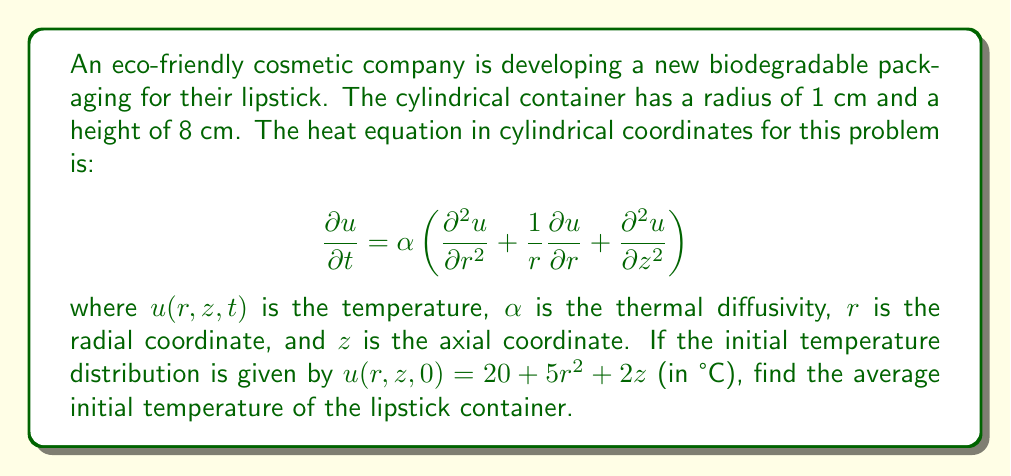Can you answer this question? To solve this problem, we need to follow these steps:

1) The average temperature is given by the volume integral of the temperature distribution divided by the volume of the cylinder:

   $$\bar{u} = \frac{\int_0^H \int_0^R u(r,z,0) \cdot 2\pi r \, dr \, dz}{\pi R^2 H}$$

   where $R$ is the radius and $H$ is the height of the cylinder.

2) Substitute the given initial temperature distribution:

   $$\bar{u} = \frac{\int_0^8 \int_0^1 (20 + 5r^2 + 2z) \cdot 2\pi r \, dr \, dz}{\pi \cdot 1^2 \cdot 8}$$

3) Evaluate the inner integral:

   $$\bar{u} = \frac{\int_0^8 \left[20\pi r^2 + \frac{5\pi r^4}{2} + 2\pi r^2 z\right]_0^1 \, dz}{8\pi}$$

   $$= \frac{\int_0^8 \left(20\pi + \frac{5\pi}{2} + 2\pi z\right) \, dz}{8\pi}$$

4) Evaluate the outer integral:

   $$\bar{u} = \frac{\left[20\pi z + \frac{5\pi}{2} z + \pi z^2\right]_0^8}{8\pi}$$

   $$= \frac{160\pi + 20\pi + 64\pi}{8\pi} = \frac{244\pi}{8\pi} = 30.5$$

5) Therefore, the average initial temperature of the lipstick container is 30.5°C.
Answer: 30.5°C 